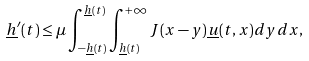Convert formula to latex. <formula><loc_0><loc_0><loc_500><loc_500>\underline { h } ^ { \prime } ( t ) \leq \mu \int _ { - \underline { h } ( t ) } ^ { \underline { h } ( t ) } \int _ { \underline { h } ( t ) } ^ { + \infty } J ( x - y ) \underline { u } ( t , x ) d y d x ,</formula> 